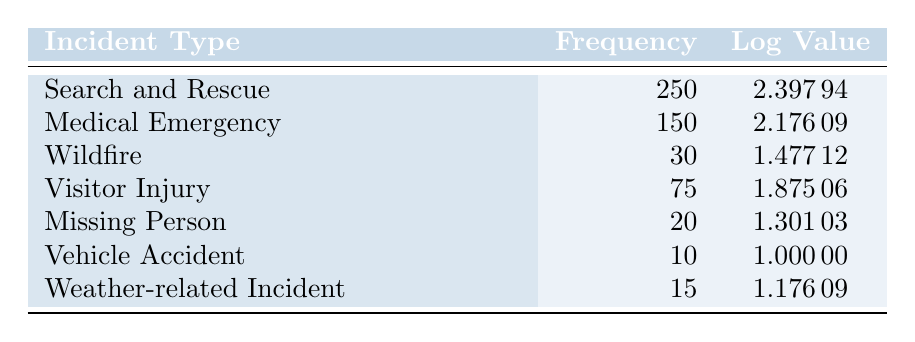What is the frequency of Search and Rescue incidents? The table lists the frequency of Search and Rescue incidents as 250.
Answer: 250 How many total incidents were reported? To find the total incidents, add the frequencies: 250 + 150 + 30 + 75 + 20 + 10 + 15 = 250 + 150 = 400, 400 + 30 = 430, 430 + 75 = 505, 505 + 20 = 525, 525 + 10 = 535, 535 + 15 = 550, giving a total of 550 incidents.
Answer: 550 Is the frequency of Visitor Injury greater than that of Vehicle Accident? The frequency of Visitor Injury is 75 and Vehicle Accident is 10; since 75 is greater than 10, the statement is true.
Answer: Yes What is the average frequency of all incidents? To find the average, sum the frequencies (250 + 150 + 30 + 75 + 20 + 10 + 15 = 550) and divide by the number of incident types (7): 550 / 7 = 78.57.
Answer: 78.57 Which incident type has the highest logarithmic value? The logarithmic values are compared: Search and Rescue (2.39794) has the highest value compared to others.
Answer: Search and Rescue How many more incidents of Medical Emergency are there compared to Weather-related Incidents? The frequency of Medical Emergency is 150 and Weather-related Incident is 15; subtracting these gives 150 - 15 = 135 more incidents.
Answer: 135 Is there an incident with a logarithmic value of exactly 1? The table shows that the only incident with a logarithmic value of 1 is Vehicle Accident, thus there is such an incident.
Answer: Yes What is the difference between the frequencies of Wildfire and Missing Person incidents? The frequency of Wildfire is 30 and Missing Person is 20; subtracting these results in 30 - 20 = 10.
Answer: 10 How many incidents have a frequency of less than 50? The incidents with frequencies less than 50 are Vehicle Accident (10), Weather-related Incident (15), and Missing Person (20), which add up to a total of 3 incidents.
Answer: 3 